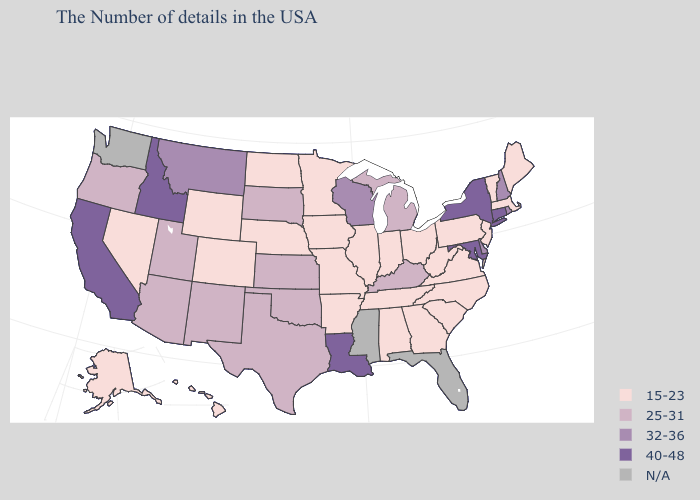What is the highest value in the USA?
Quick response, please. 40-48. Name the states that have a value in the range N/A?
Keep it brief. Florida, Mississippi, Washington. Among the states that border New Jersey , does New York have the lowest value?
Give a very brief answer. No. Which states have the lowest value in the USA?
Answer briefly. Maine, Massachusetts, Vermont, New Jersey, Pennsylvania, Virginia, North Carolina, South Carolina, West Virginia, Ohio, Georgia, Indiana, Alabama, Tennessee, Illinois, Missouri, Arkansas, Minnesota, Iowa, Nebraska, North Dakota, Wyoming, Colorado, Nevada, Alaska, Hawaii. Does Rhode Island have the highest value in the Northeast?
Keep it brief. No. Does North Carolina have the lowest value in the USA?
Give a very brief answer. Yes. Does the first symbol in the legend represent the smallest category?
Quick response, please. Yes. Among the states that border Maine , which have the lowest value?
Answer briefly. New Hampshire. What is the value of Connecticut?
Be succinct. 40-48. Name the states that have a value in the range 15-23?
Write a very short answer. Maine, Massachusetts, Vermont, New Jersey, Pennsylvania, Virginia, North Carolina, South Carolina, West Virginia, Ohio, Georgia, Indiana, Alabama, Tennessee, Illinois, Missouri, Arkansas, Minnesota, Iowa, Nebraska, North Dakota, Wyoming, Colorado, Nevada, Alaska, Hawaii. Name the states that have a value in the range 25-31?
Be succinct. Michigan, Kentucky, Kansas, Oklahoma, Texas, South Dakota, New Mexico, Utah, Arizona, Oregon. Among the states that border New Jersey , which have the highest value?
Answer briefly. New York. Name the states that have a value in the range 25-31?
Answer briefly. Michigan, Kentucky, Kansas, Oklahoma, Texas, South Dakota, New Mexico, Utah, Arizona, Oregon. 